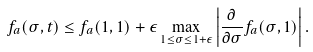<formula> <loc_0><loc_0><loc_500><loc_500>f _ { a } ( \sigma , t ) \leq f _ { a } ( 1 , 1 ) + \epsilon \max _ { 1 \leq \sigma \leq 1 + \epsilon } \left | \frac { \partial } { \partial \sigma } f _ { a } ( \sigma , 1 ) \right | .</formula> 